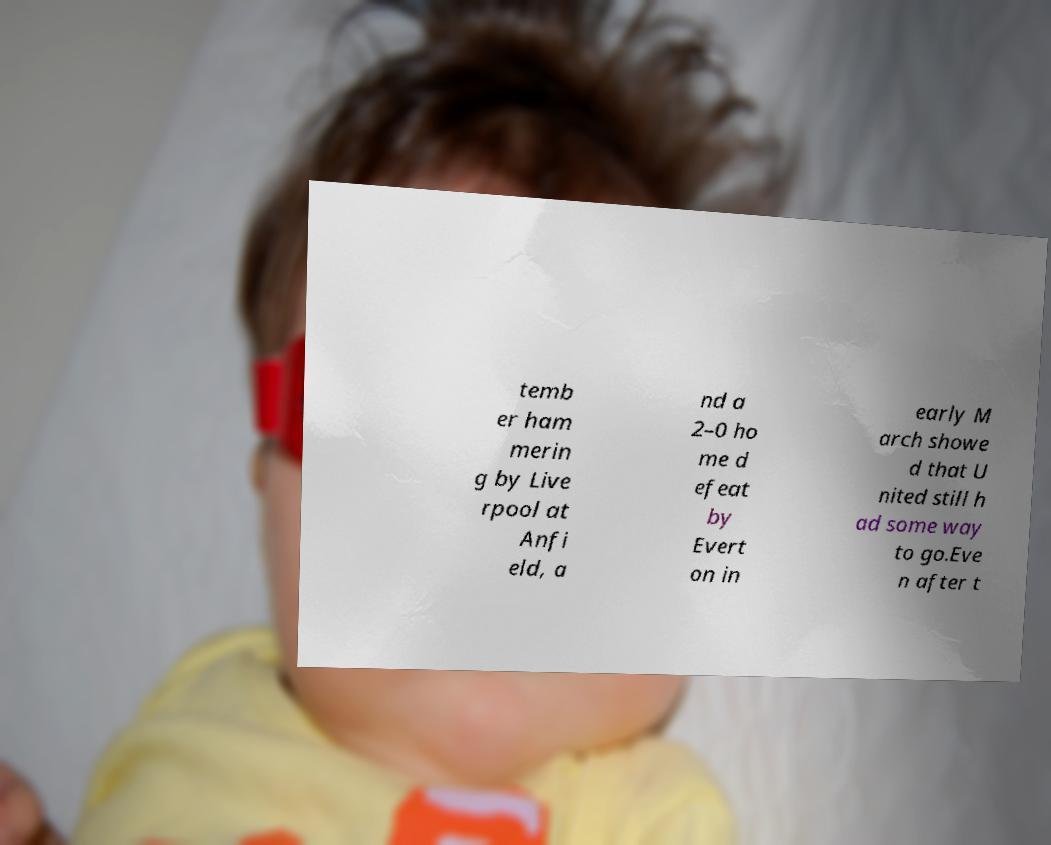Please read and relay the text visible in this image. What does it say? temb er ham merin g by Live rpool at Anfi eld, a nd a 2–0 ho me d efeat by Evert on in early M arch showe d that U nited still h ad some way to go.Eve n after t 